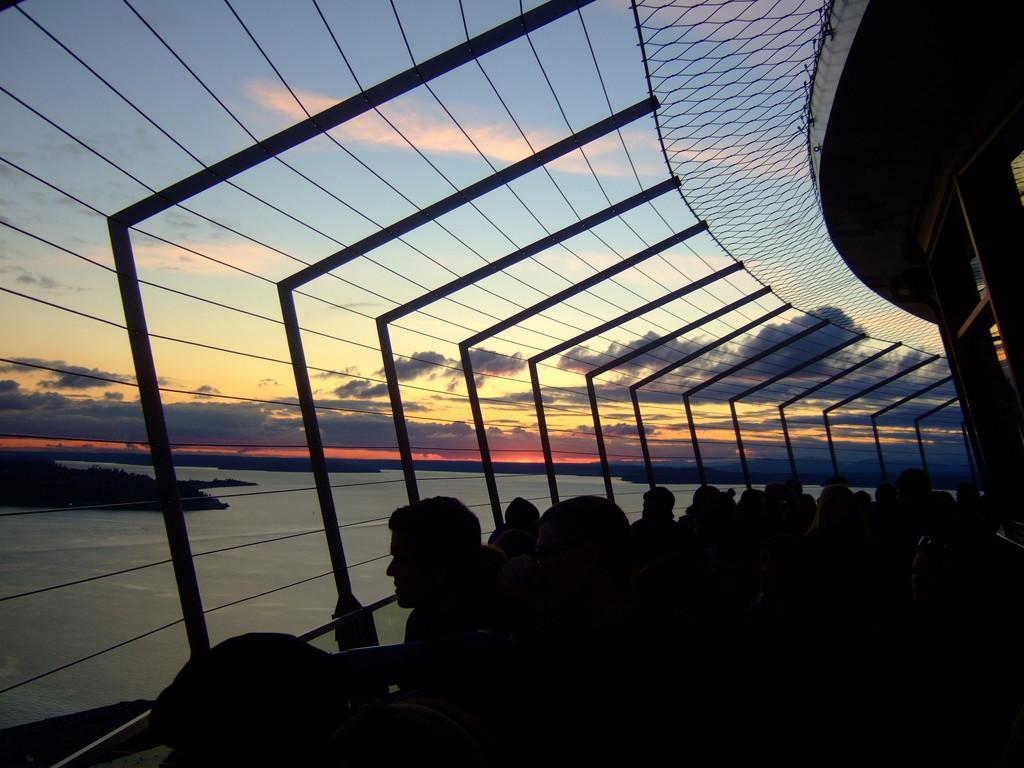Please provide a concise description of this image. In this image there are few people standing near a fence in the building, there are few trees, water and some clouds in the sky. 